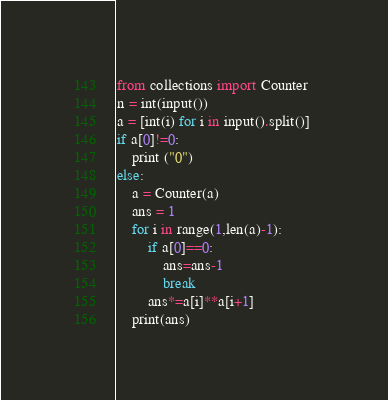Convert code to text. <code><loc_0><loc_0><loc_500><loc_500><_Python_>from collections import Counter
n = int(input())
a = [int(i) for i in input().split()] 
if a[0]!=0:
    print ("0")
else:
    a = Counter(a)
    ans = 1
    for i in range(1,len(a)-1):
        if a[0]==0:
            ans=ans-1
            break
        ans*=a[i]**a[i+1]
    print(ans)
</code> 